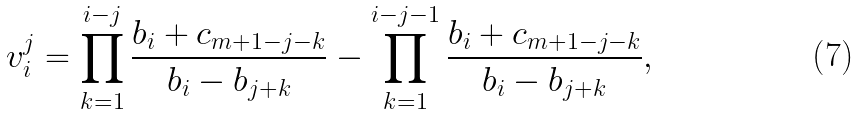Convert formula to latex. <formula><loc_0><loc_0><loc_500><loc_500>v _ { i } ^ { j } = \prod _ { k = 1 } ^ { i - j } \frac { b _ { i } + c _ { m + 1 - j - k } } { b _ { i } - b _ { j + k } } - \prod _ { k = 1 } ^ { i - j - 1 } \frac { b _ { i } + c _ { m + 1 - j - k } } { b _ { i } - b _ { j + k } } ,</formula> 